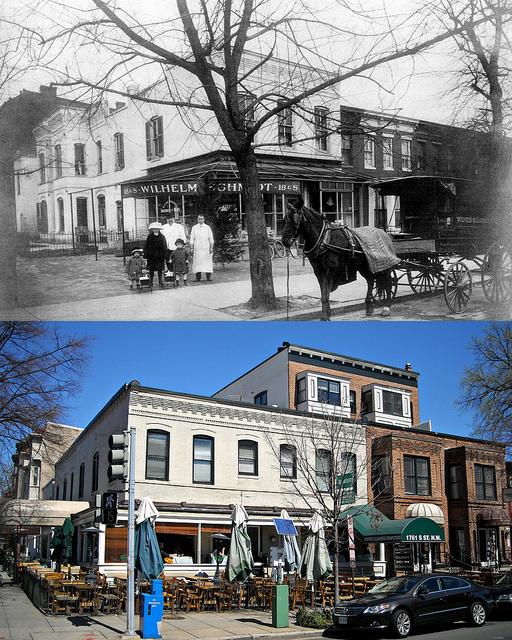Is there a horse in both photos?
Quick response, please. No. Is the same building in both photo's?
Concise answer only. No. Which shot is newer?
Short answer required. Bottom. 